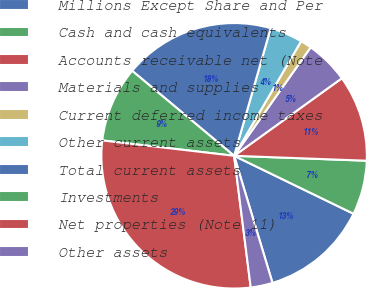Convert chart. <chart><loc_0><loc_0><loc_500><loc_500><pie_chart><fcel>Millions Except Share and Per<fcel>Cash and cash equivalents<fcel>Accounts receivable net (Note<fcel>Materials and supplies<fcel>Current deferred income taxes<fcel>Other current assets<fcel>Total current assets<fcel>Investments<fcel>Net properties (Note 11)<fcel>Other assets<nl><fcel>13.14%<fcel>6.6%<fcel>10.52%<fcel>5.29%<fcel>1.36%<fcel>3.98%<fcel>18.38%<fcel>9.21%<fcel>28.84%<fcel>2.67%<nl></chart> 